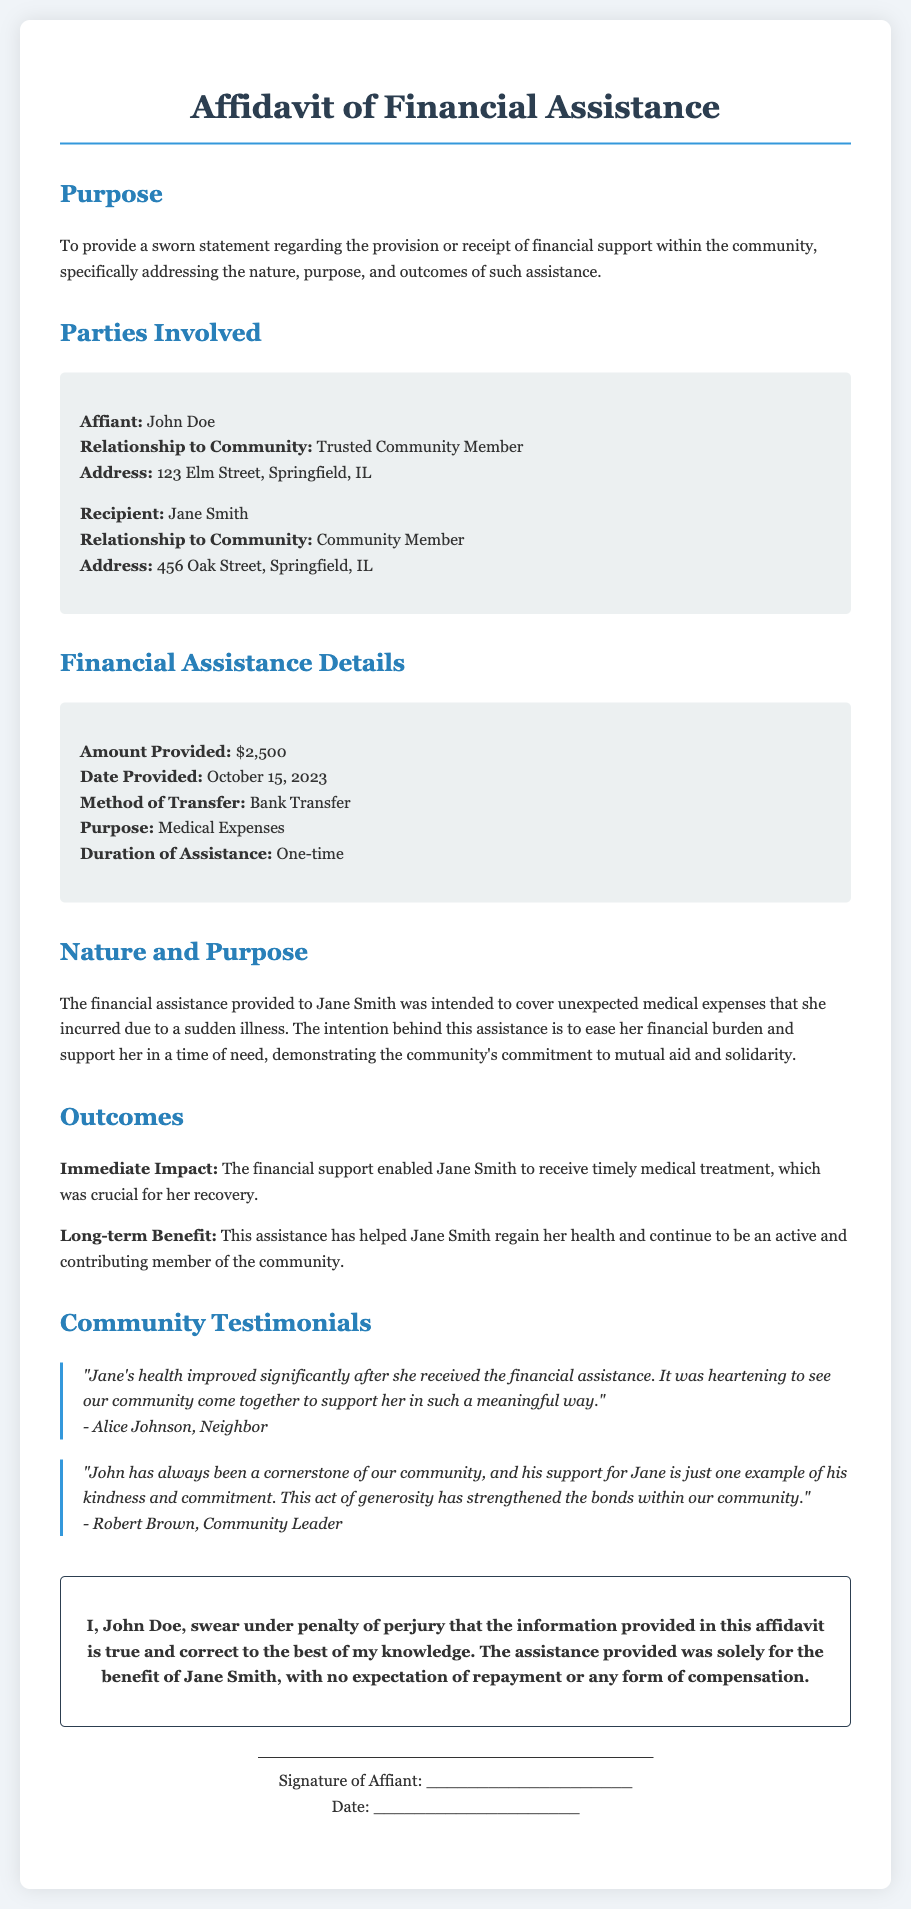what is the name of the affiant? The affiant's name is mentioned in the document as the person providing the sworn statement.
Answer: John Doe what amount of financial assistance was provided? The amount of financial assistance is specifically stated under financial assistance details.
Answer: $2,500 who is the recipient of the financial assistance? The recipient of the financial assistance is the individual mentioned in the document as receiving help from the affiant.
Answer: Jane Smith what was the purpose of the financial assistance? The document explicitly states the intended use of the funds given to the recipient.
Answer: Medical Expenses on what date was the financial assistance provided? The date the financial assistance was given is provided in the financial assistance details section of the document.
Answer: October 15, 2023 what method was used to transfer the financial assistance? The method of transfer is mentioned in the financial assistance details section, indicating how the funds were delivered.
Answer: Bank Transfer how did the financial assistance impact Jane Smith's health? The immediate effect of the assistance on the recipient's health is described in the outcomes section of the document.
Answer: Enabled timely medical treatment who provided a testimonial about Jane Smith's health improvement? The document includes testimonials from community members, indicating who recognized the improvement.
Answer: Alice Johnson what was the relationship of the affiant to the community? The affiant's relationship to the community is stated to indicate their involvement and position.
Answer: Trusted Community Member 